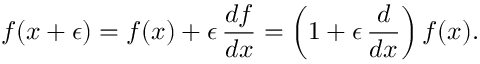<formula> <loc_0><loc_0><loc_500><loc_500>f ( x + \epsilon ) = f ( x ) + \epsilon \, { \frac { d f } { d x } } = \left ( 1 + \epsilon \, { \frac { d } { d x } } \right ) f ( x ) .</formula> 